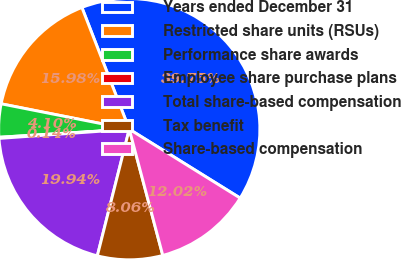<chart> <loc_0><loc_0><loc_500><loc_500><pie_chart><fcel>Years ended December 31<fcel>Restricted share units (RSUs)<fcel>Performance share awards<fcel>Employee share purchase plans<fcel>Total share-based compensation<fcel>Tax benefit<fcel>Share-based compensation<nl><fcel>39.75%<fcel>15.98%<fcel>4.1%<fcel>0.14%<fcel>19.94%<fcel>8.06%<fcel>12.02%<nl></chart> 